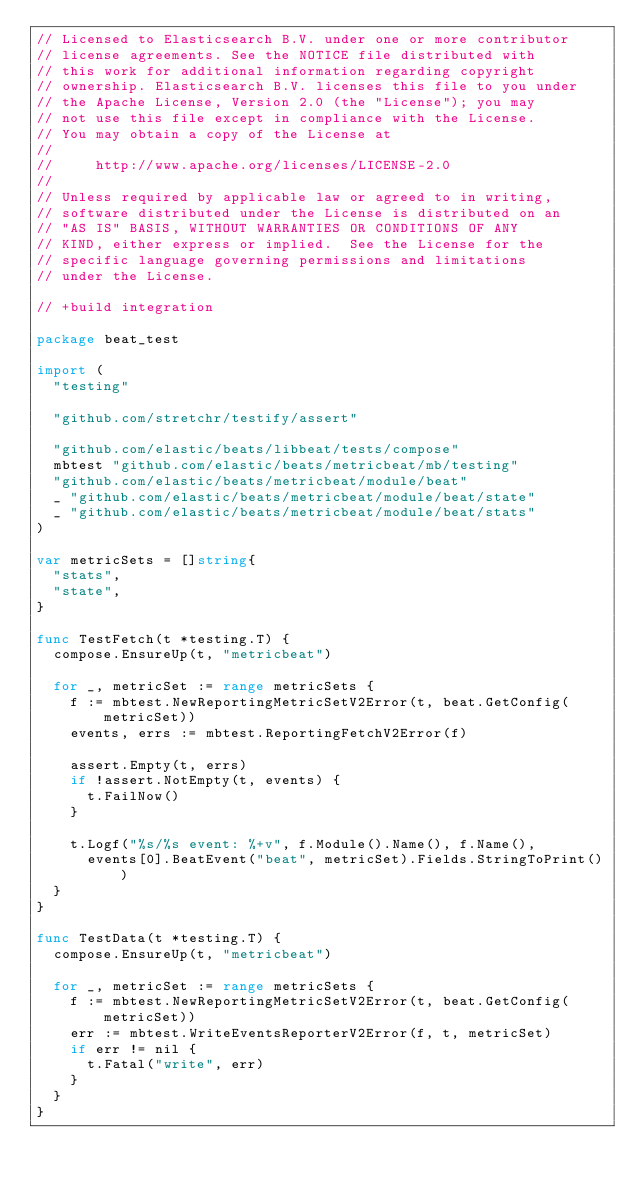Convert code to text. <code><loc_0><loc_0><loc_500><loc_500><_Go_>// Licensed to Elasticsearch B.V. under one or more contributor
// license agreements. See the NOTICE file distributed with
// this work for additional information regarding copyright
// ownership. Elasticsearch B.V. licenses this file to you under
// the Apache License, Version 2.0 (the "License"); you may
// not use this file except in compliance with the License.
// You may obtain a copy of the License at
//
//     http://www.apache.org/licenses/LICENSE-2.0
//
// Unless required by applicable law or agreed to in writing,
// software distributed under the License is distributed on an
// "AS IS" BASIS, WITHOUT WARRANTIES OR CONDITIONS OF ANY
// KIND, either express or implied.  See the License for the
// specific language governing permissions and limitations
// under the License.

// +build integration

package beat_test

import (
	"testing"

	"github.com/stretchr/testify/assert"

	"github.com/elastic/beats/libbeat/tests/compose"
	mbtest "github.com/elastic/beats/metricbeat/mb/testing"
	"github.com/elastic/beats/metricbeat/module/beat"
	_ "github.com/elastic/beats/metricbeat/module/beat/state"
	_ "github.com/elastic/beats/metricbeat/module/beat/stats"
)

var metricSets = []string{
	"stats",
	"state",
}

func TestFetch(t *testing.T) {
	compose.EnsureUp(t, "metricbeat")

	for _, metricSet := range metricSets {
		f := mbtest.NewReportingMetricSetV2Error(t, beat.GetConfig(metricSet))
		events, errs := mbtest.ReportingFetchV2Error(f)

		assert.Empty(t, errs)
		if !assert.NotEmpty(t, events) {
			t.FailNow()
		}

		t.Logf("%s/%s event: %+v", f.Module().Name(), f.Name(),
			events[0].BeatEvent("beat", metricSet).Fields.StringToPrint())
	}
}

func TestData(t *testing.T) {
	compose.EnsureUp(t, "metricbeat")

	for _, metricSet := range metricSets {
		f := mbtest.NewReportingMetricSetV2Error(t, beat.GetConfig(metricSet))
		err := mbtest.WriteEventsReporterV2Error(f, t, metricSet)
		if err != nil {
			t.Fatal("write", err)
		}
	}
}
</code> 